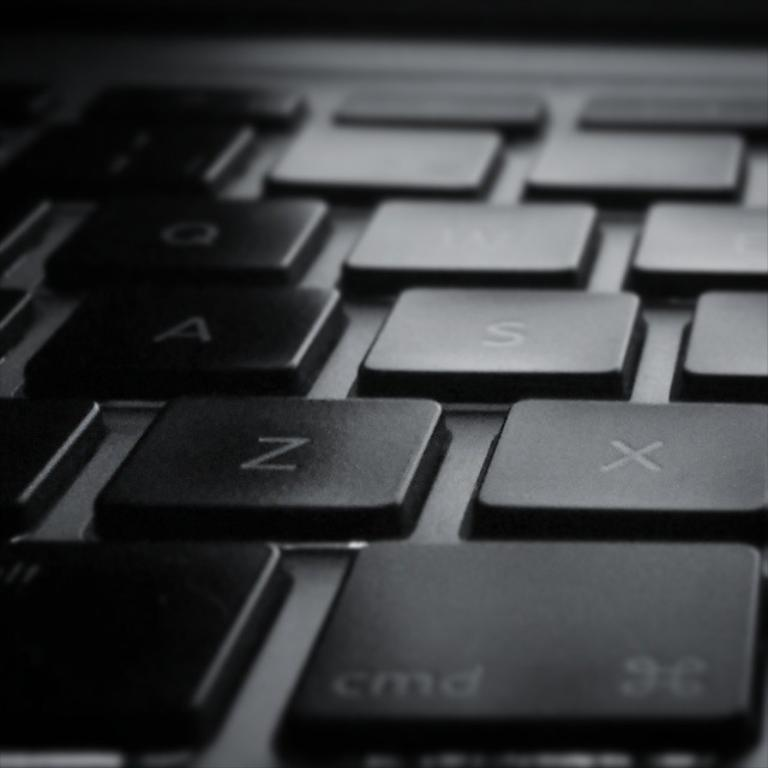<image>
Give a short and clear explanation of the subsequent image. the letter S is on the keyboard and also X 